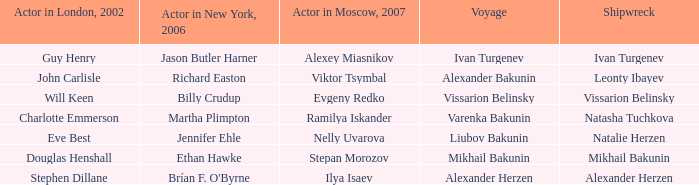Who was the actor in London in 2002 with the shipwreck of Leonty Ibayev? John Carlisle. 